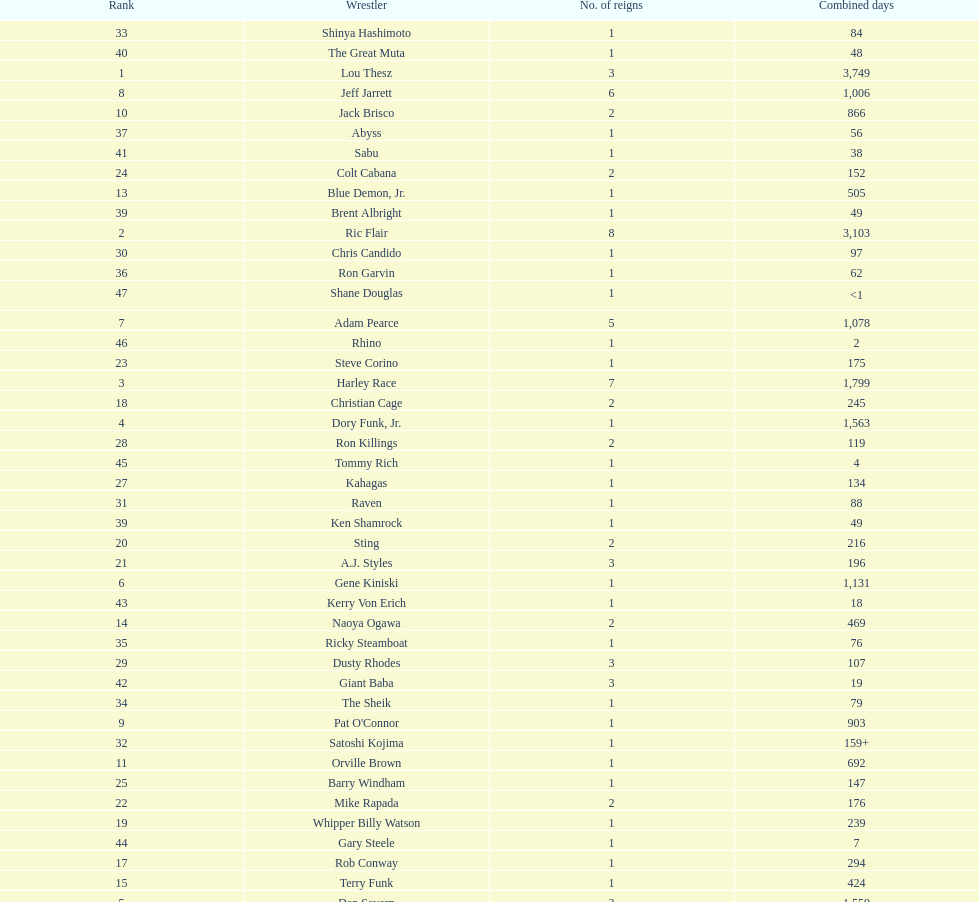How long did orville brown remain nwa world heavyweight champion? 692 days. 